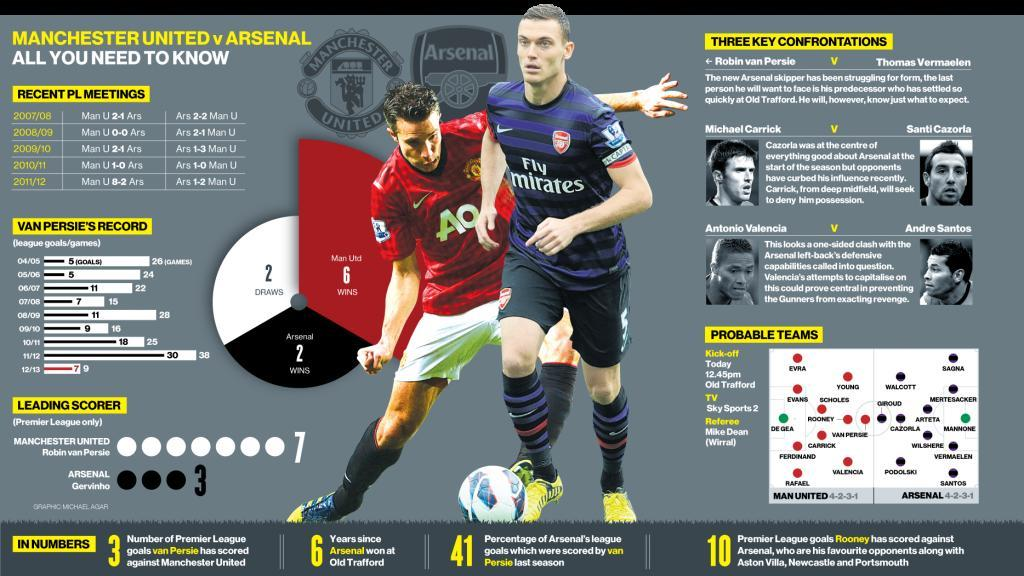what are the other favourtie opponents of Rooney other than Newcastle and Portsmouth
Answer the question with a short phrase. Arsenal, Aston Villa who are the 2 goal keepers shown in the probable teams De Gea, Mannone what is the colour of the shoes of the footballer with blue T shirt, yellow or red yellow What is written below the logo on the blue T shirt Fly mirates 